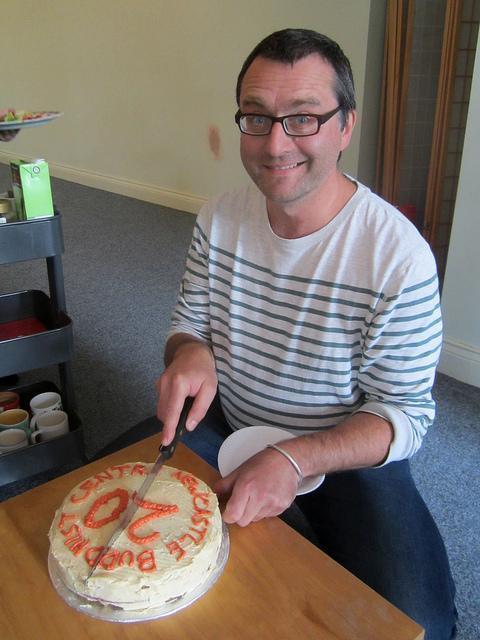How many slices are taken out of the cake?
Give a very brief answer. 0. How many people are in the picture?
Give a very brief answer. 1. How many cakes are in the picture?
Give a very brief answer. 1. How many white dogs are in the image?
Give a very brief answer. 0. 